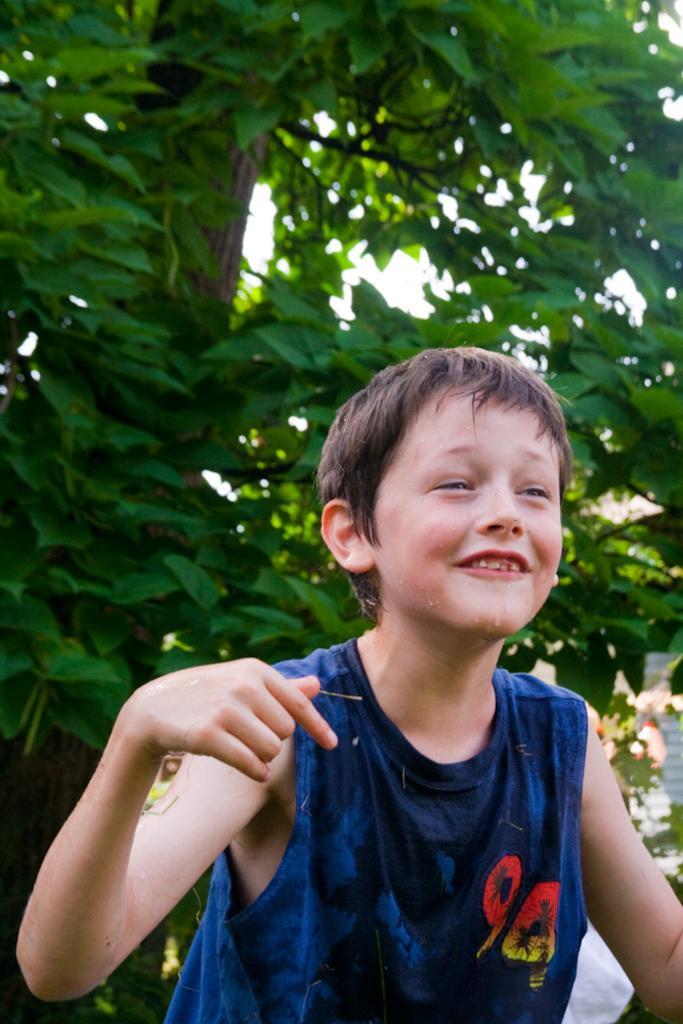Can you describe this image briefly? This image is taken outdoors. In the background there is a tree with leaves, stems and branches. In the middle of the image there is a kid. 